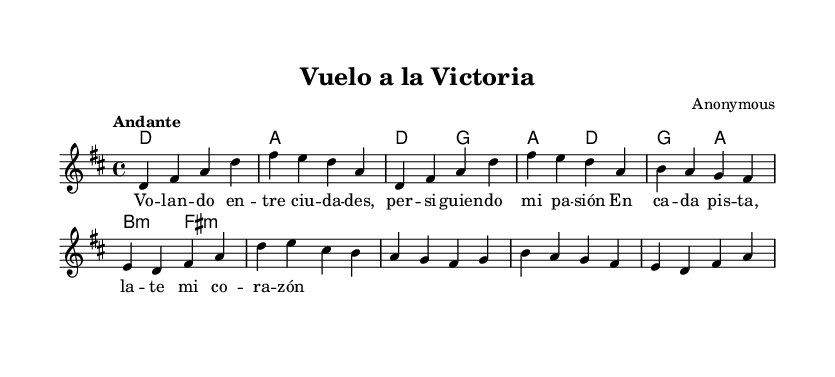What is the key signature of this music? The key signature is indicated in the beginning of the sheet music with two sharps, corresponding to D major.
Answer: D major What is the time signature of this music? The time signature is shown right after the key signature; it indicates that there are four beats per measure.
Answer: 4/4 What is the tempo marking for this piece? The tempo marking, placed at the beginning, indicates the speed of the music, which is "Andante," suggesting a moderate pace.
Answer: Andante How many beats are in the chorus section? By counting the measures and beats in the chorus part, we note there are a total of 8 beats in 2 measures.
Answer: 8 What is the starting note of the melody? The first note of the melody, indicated at the start of the melody line, is D.
Answer: D What is the relationship between the first chord and the melody's first note? The first chord is D major, and the melody starts on the note D, which is the tonic of that chord, establishing a strong harmonic foundation.
Answer: Tonic What lyrical theme can be inferred from the words of the verse? The verse lyrics express longing and yearning, themes commonly found in nostalgic pop ballads, inferring emotional depth.
Answer: Longing 